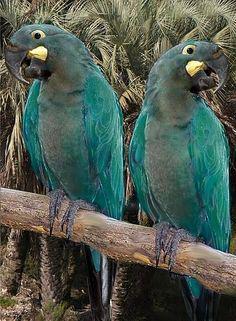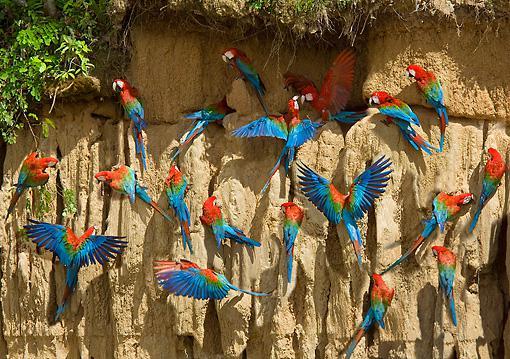The first image is the image on the left, the second image is the image on the right. Evaluate the accuracy of this statement regarding the images: "The left image shows a parrot with wings extended in flight.". Is it true? Answer yes or no. No. 